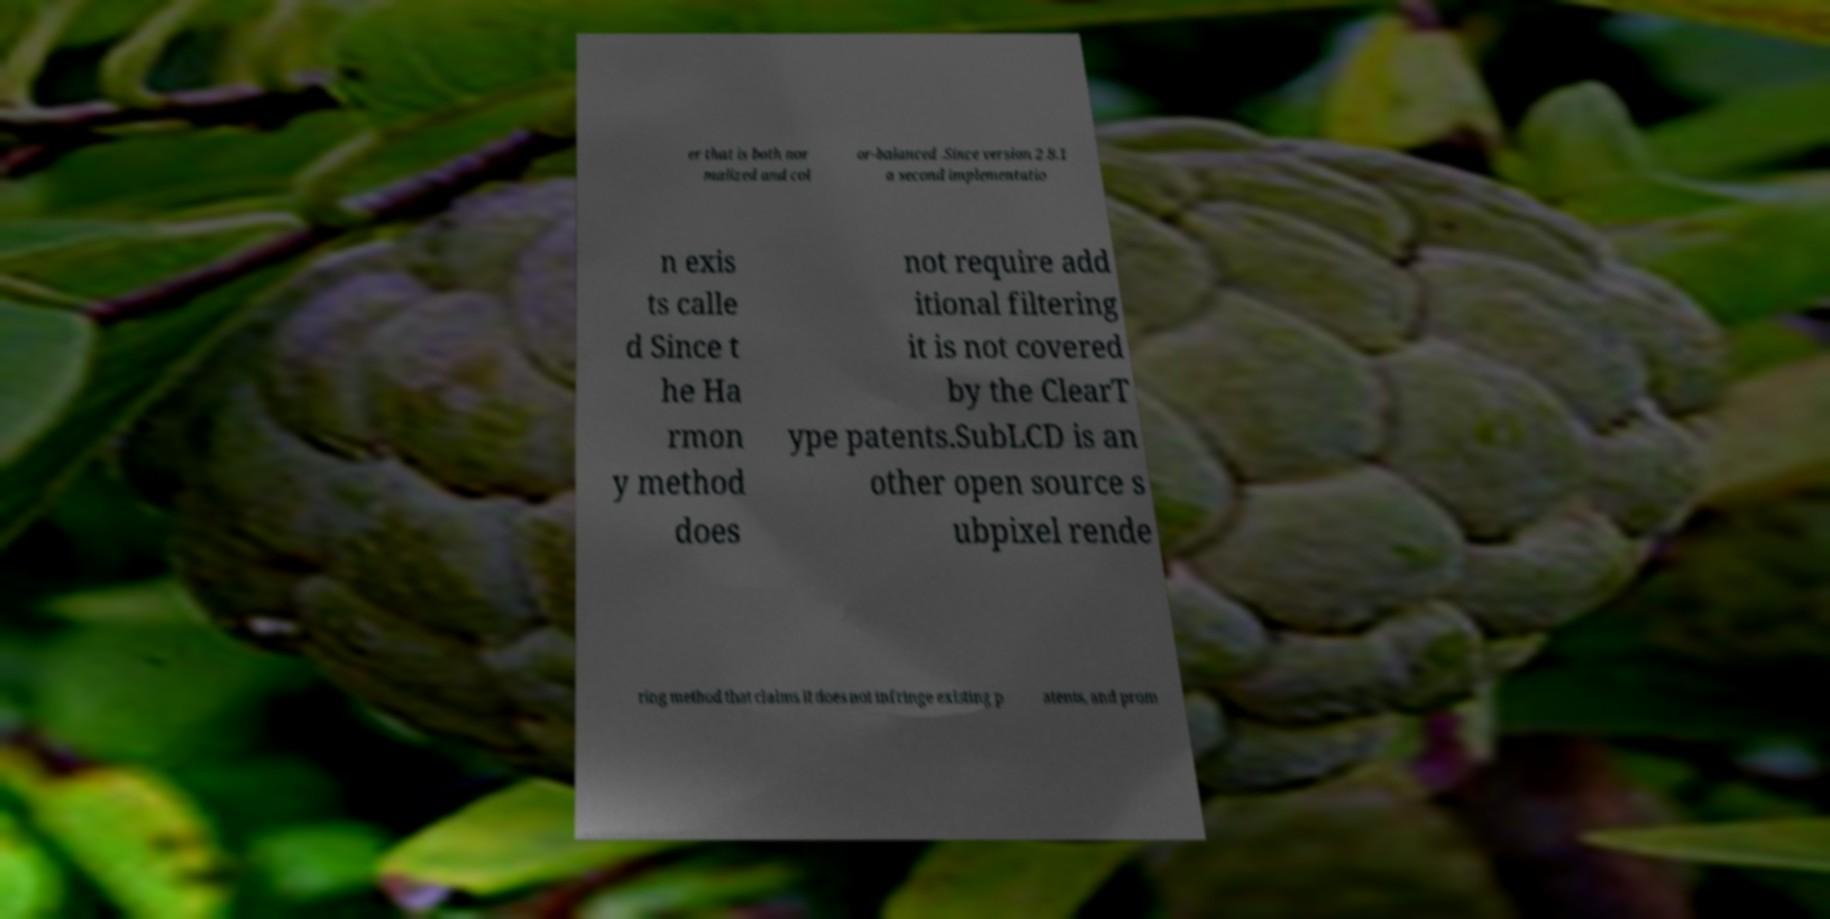Could you assist in decoding the text presented in this image and type it out clearly? er that is both nor malized and col or-balanced .Since version 2.8.1 a second implementatio n exis ts calle d Since t he Ha rmon y method does not require add itional filtering it is not covered by the ClearT ype patents.SubLCD is an other open source s ubpixel rende ring method that claims it does not infringe existing p atents, and prom 